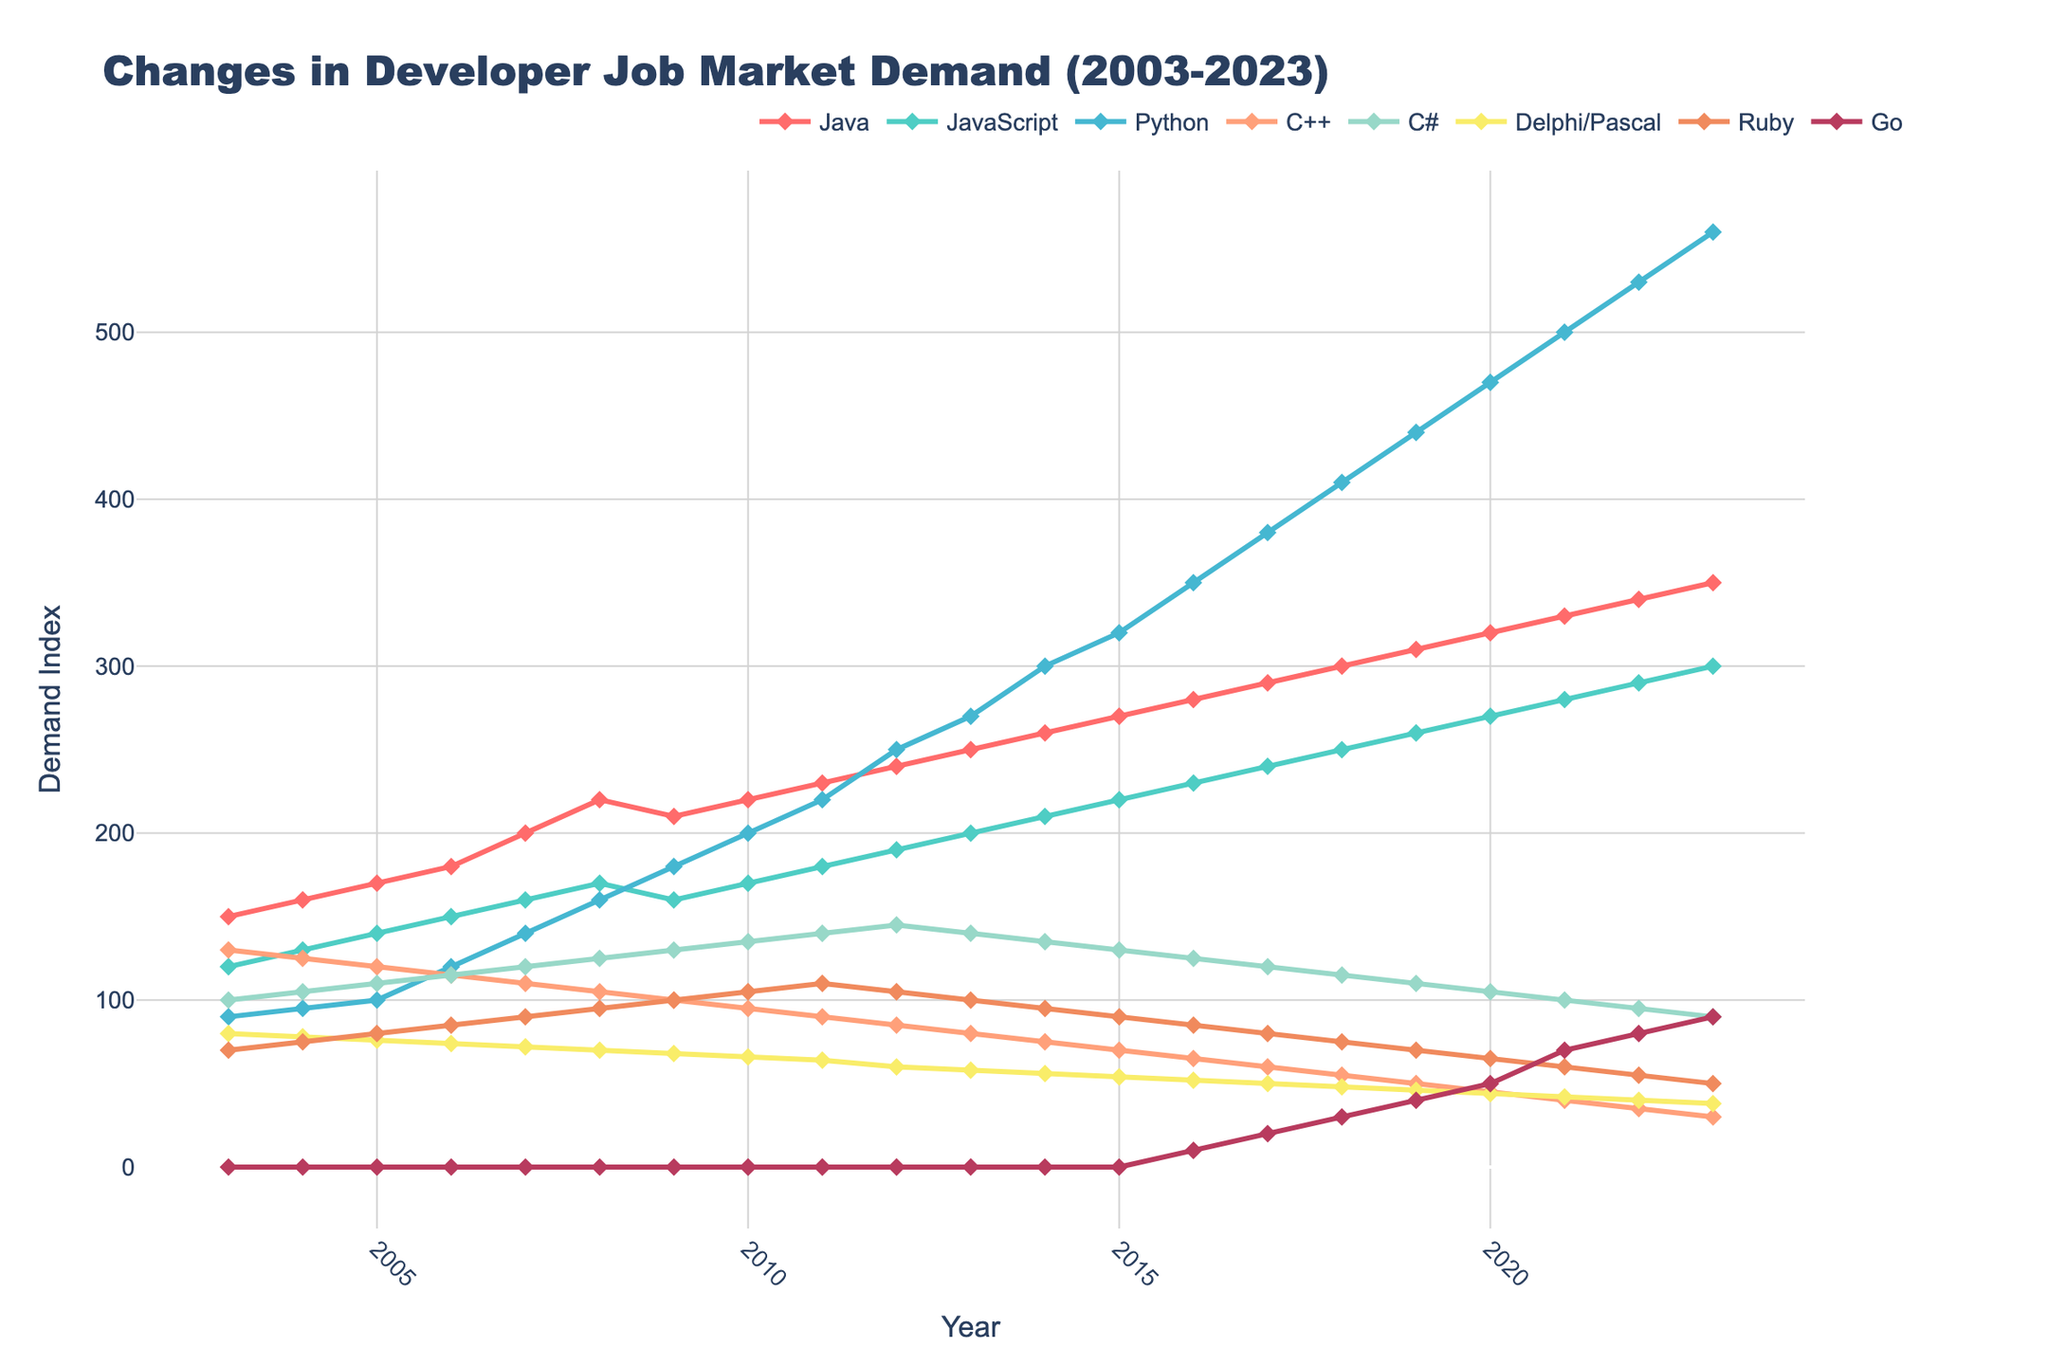What is the title of the plot? The title of the plot is usually located at the top and it summarizes the main point of the data being visualized. The title here is "Changes in Developer Job Market Demand (2003-2023)".
Answer: Changes in Developer Job Market Demand (2003-2023) Which programming language had the highest demand in 2023? To answer this, look at the points for the year 2023 on the plot and identify which line has the highest value. Python reaches the highest point in 2023.
Answer: Python What is the color of the line representing the demand for Delphi/Pascal? Identify the line for Delphi/Pascal and look at its color. The line for Delphi/Pascal is colored yellow.
Answer: Yellow How did the demand for Go change from 2016 to 2023? Observe the points for Go from 2016 to 2023 and compare them. In 2016, Go has a demand of 10, which increases steadily to 90 by 2023.
Answer: Increased What was the demand index difference between Ruby and Java in 2010? Find the values for Ruby and Java in 2010. Ruby is at 105, Java is at 220. Subtract Ruby's value from Java's value to get the difference: 220 - 105.
Answer: 115 In which year did Python overtake Java in demand? Compare the lines for Python and Java and find the exact year when Python's line goes above Java. Python surpasses Java in 2018.
Answer: 2018 Which programming languages showed a steady increase in demand over the entire period? Look at the trends of all lines from 2003 to 2023 and identify which ones are continuously increasing. Python, JavaScript, and Go show a steady increase.
Answer: Python, JavaScript, Go Compare the demand trends for C++ and C# from 2003 to 2023. Which one is decreasing faster? Observe the slope of the trend lines for C++ and C# from 2003 to 2023. C++ declines more sharply compared to C# particularly after 2007.
Answer: C++ What is the average demand index for JavaScript from 2010 to 2015? Find values for JavaScript from 2010 (170) to 2015 (220) and calculate the average: (170 + 180 + 190 + 200 + 210 + 220) / 6 = 195
Answer: 195 Which year saw the most significant jump in demand for Python? By how much? Find the year with the largest vertical jump for Python. The largest increase happens between 2016 (350) and 2017 (380). The difference is 30.
Answer: 2017, 30 